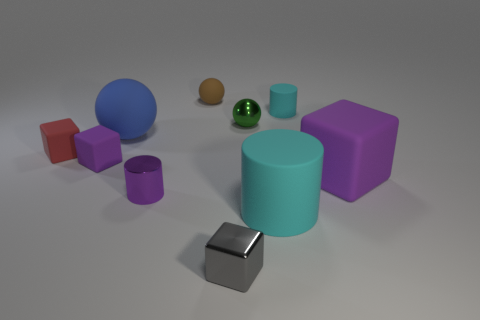Subtract all cylinders. How many objects are left? 7 Add 7 big blue objects. How many big blue objects are left? 8 Add 1 tiny rubber cylinders. How many tiny rubber cylinders exist? 2 Subtract 0 brown cylinders. How many objects are left? 10 Subtract all tiny purple metal balls. Subtract all large blue matte spheres. How many objects are left? 9 